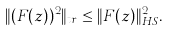Convert formula to latex. <formula><loc_0><loc_0><loc_500><loc_500>\| ( F ( z ) ) ^ { 2 } \| _ { t r } \leq \| F ( z ) \| _ { H S } ^ { 2 } .</formula> 